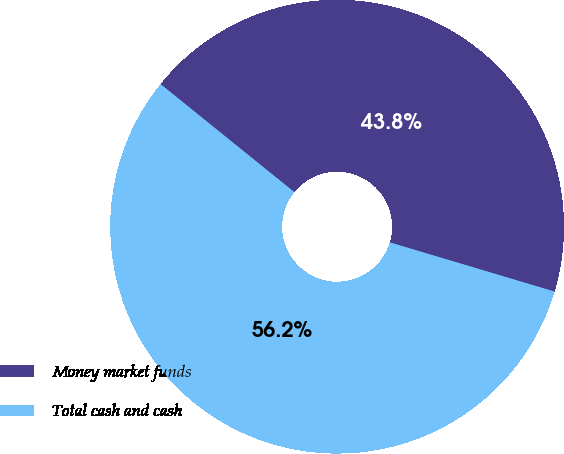<chart> <loc_0><loc_0><loc_500><loc_500><pie_chart><fcel>Money market funds<fcel>Total cash and cash<nl><fcel>43.81%<fcel>56.19%<nl></chart> 